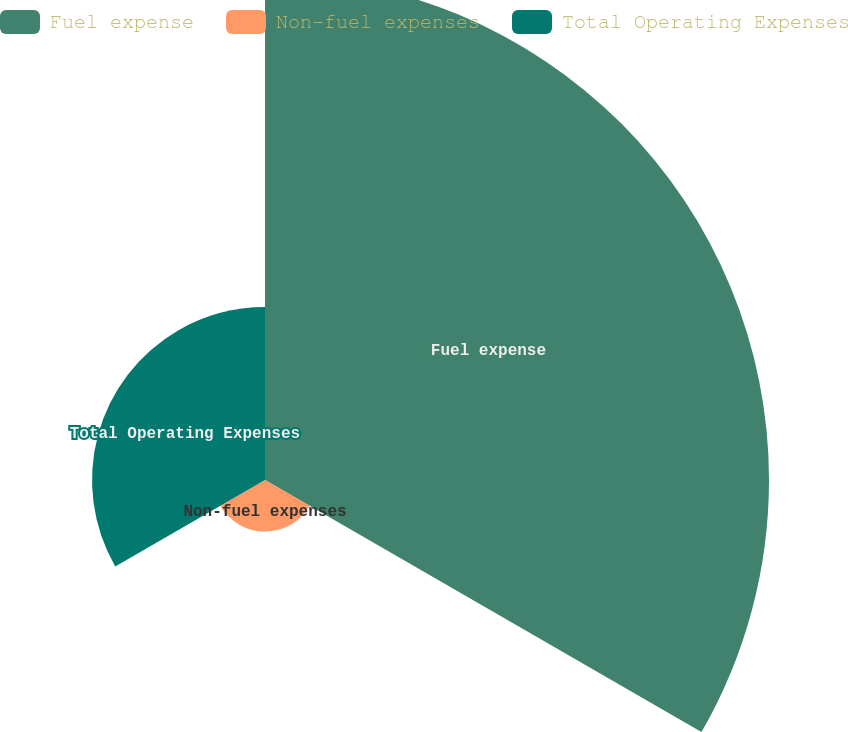Convert chart. <chart><loc_0><loc_0><loc_500><loc_500><pie_chart><fcel>Fuel expense<fcel>Non-fuel expenses<fcel>Total Operating Expenses<nl><fcel>69.18%<fcel>7.08%<fcel>23.74%<nl></chart> 